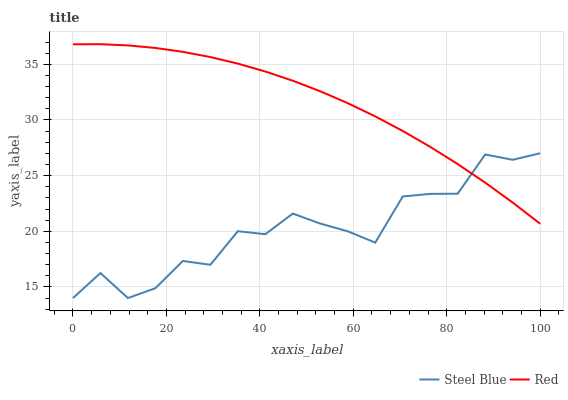Does Steel Blue have the minimum area under the curve?
Answer yes or no. Yes. Does Red have the minimum area under the curve?
Answer yes or no. No. Is Steel Blue the roughest?
Answer yes or no. Yes. Is Red the roughest?
Answer yes or no. No. Does Red have the lowest value?
Answer yes or no. No. 